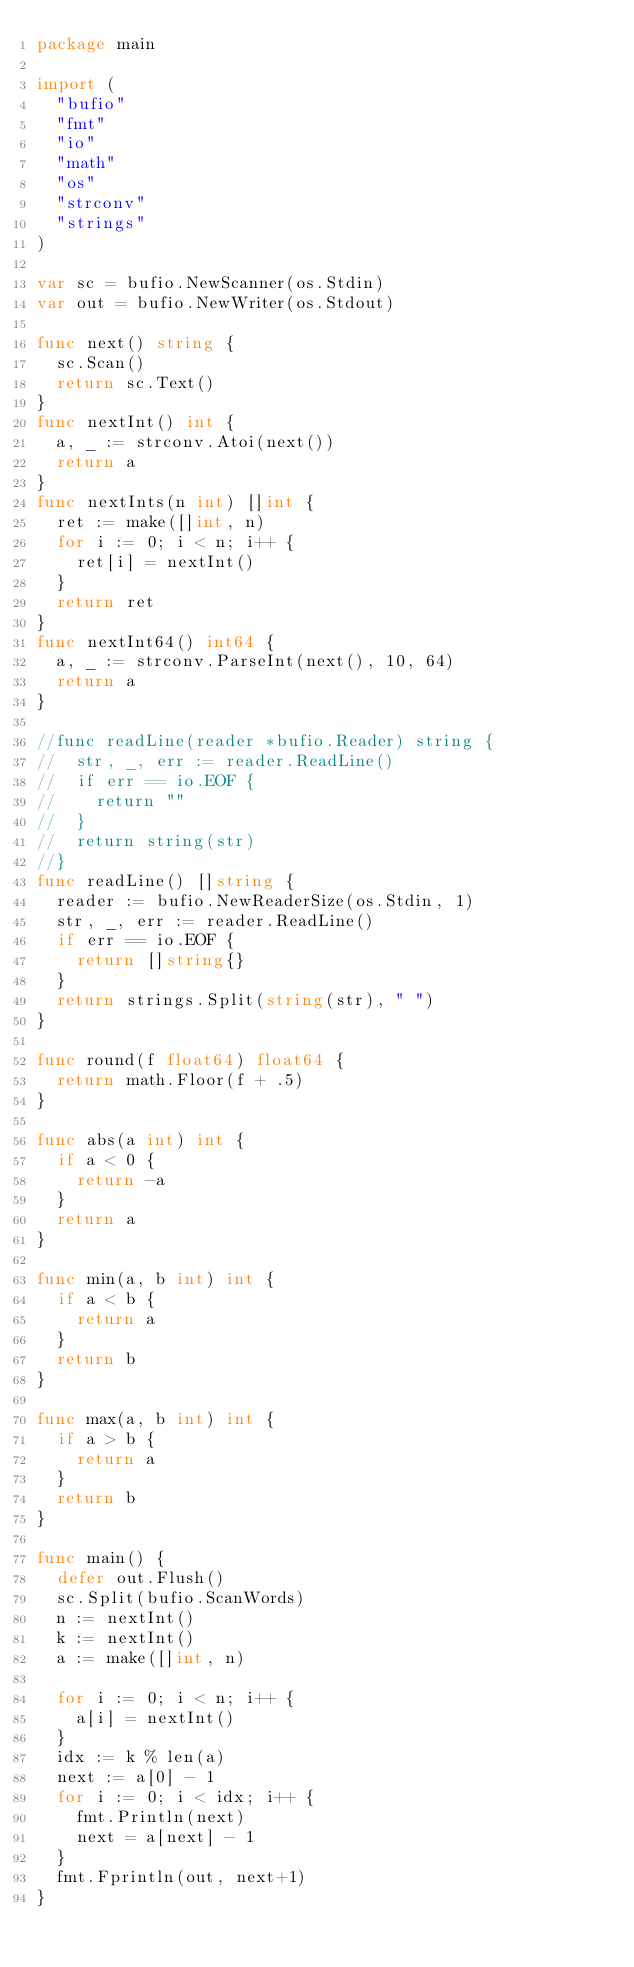Convert code to text. <code><loc_0><loc_0><loc_500><loc_500><_Go_>package main

import (
	"bufio"
	"fmt"
	"io"
	"math"
	"os"
	"strconv"
	"strings"
)

var sc = bufio.NewScanner(os.Stdin)
var out = bufio.NewWriter(os.Stdout)

func next() string {
	sc.Scan()
	return sc.Text()
}
func nextInt() int {
	a, _ := strconv.Atoi(next())
	return a
}
func nextInts(n int) []int {
	ret := make([]int, n)
	for i := 0; i < n; i++ {
		ret[i] = nextInt()
	}
	return ret
}
func nextInt64() int64 {
	a, _ := strconv.ParseInt(next(), 10, 64)
	return a
}

//func readLine(reader *bufio.Reader) string {
//	str, _, err := reader.ReadLine()
//	if err == io.EOF {
//		return ""
//	}
//	return string(str)
//}
func readLine() []string {
	reader := bufio.NewReaderSize(os.Stdin, 1)
	str, _, err := reader.ReadLine()
	if err == io.EOF {
		return []string{}
	}
	return strings.Split(string(str), " ")
}

func round(f float64) float64 {
	return math.Floor(f + .5)
}

func abs(a int) int {
	if a < 0 {
		return -a
	}
	return a
}

func min(a, b int) int {
	if a < b {
		return a
	}
	return b
}

func max(a, b int) int {
	if a > b {
		return a
	}
	return b
}

func main() {
	defer out.Flush()
	sc.Split(bufio.ScanWords)
	n := nextInt()
	k := nextInt()
	a := make([]int, n)

	for i := 0; i < n; i++ {
		a[i] = nextInt()
	}
	idx := k % len(a)
	next := a[0] - 1
	for i := 0; i < idx; i++ {
		fmt.Println(next)
		next = a[next] - 1
	}
	fmt.Fprintln(out, next+1)
}
</code> 